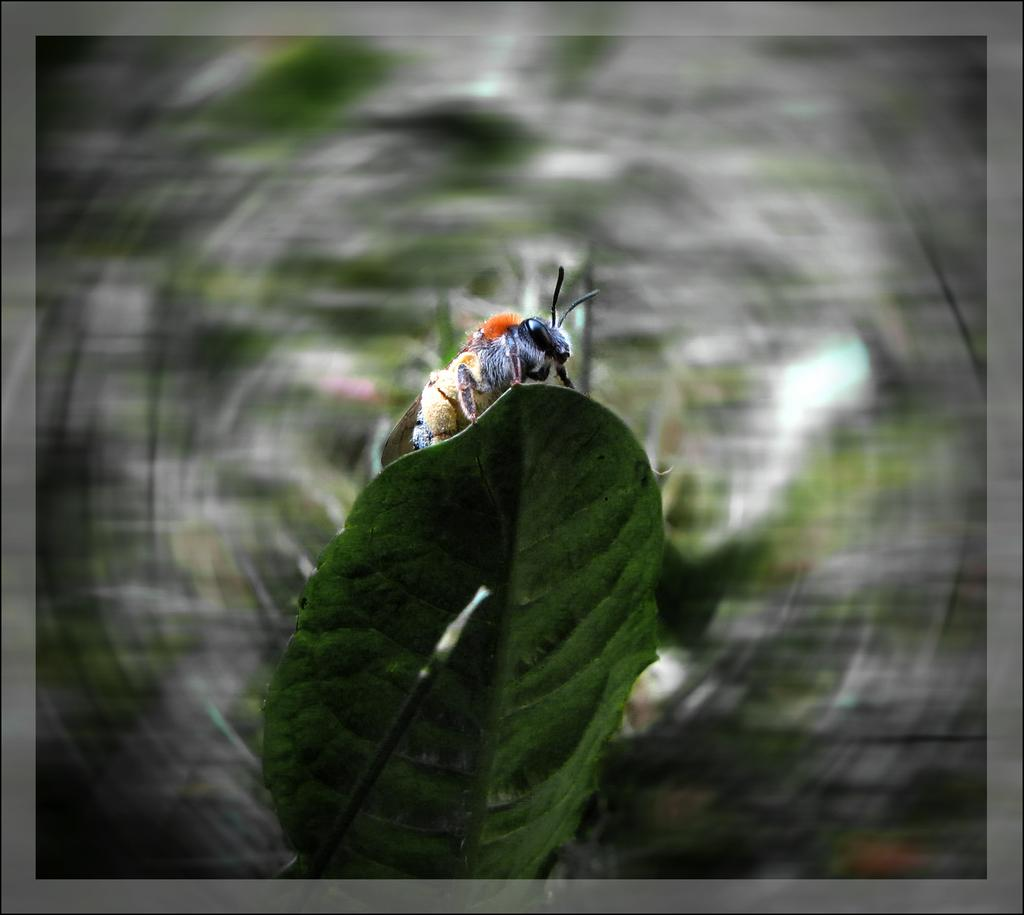What is present on the green leaf in the image? There is an insect on a green leaf in the image. What can be seen in front of the green leaf? There is an object in front of the green leaf in the image. How would you describe the background of the image? The background of the image is blurred. What type of border is present around the image? There is a gray border around the image. How many girls are visible in the image? There are no girls present in the image. What type of glass is being used by the insect in the image? There is no glass present in the image; it features an insect on a green leaf. 